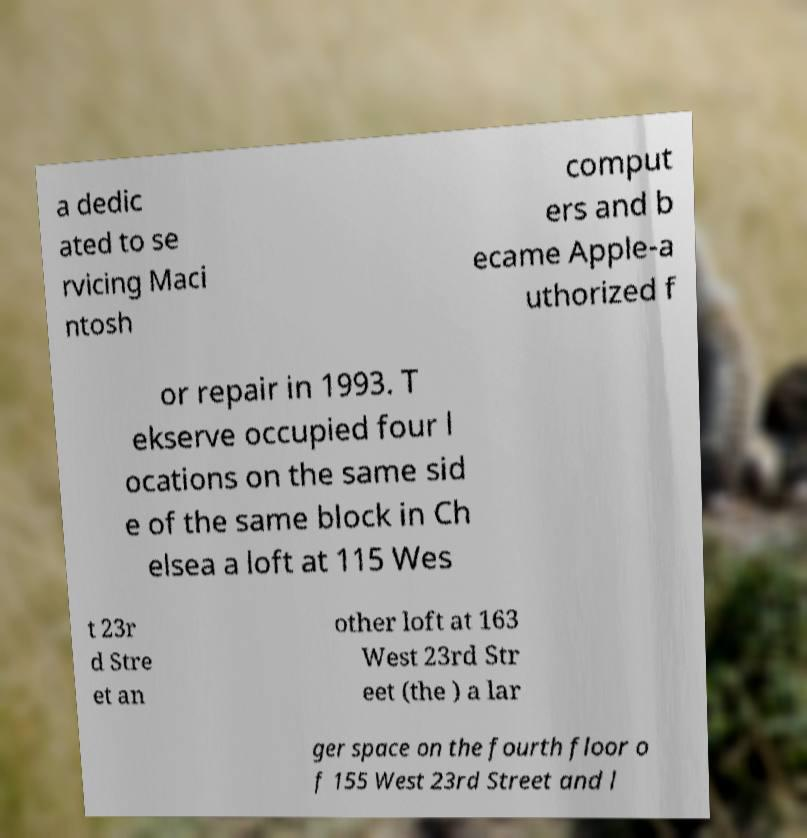Please identify and transcribe the text found in this image. a dedic ated to se rvicing Maci ntosh comput ers and b ecame Apple-a uthorized f or repair in 1993. T ekserve occupied four l ocations on the same sid e of the same block in Ch elsea a loft at 115 Wes t 23r d Stre et an other loft at 163 West 23rd Str eet (the ) a lar ger space on the fourth floor o f 155 West 23rd Street and l 